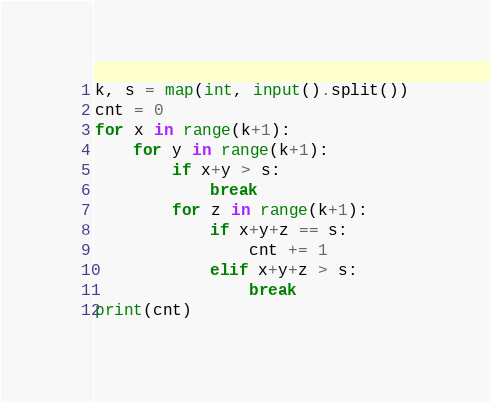Convert code to text. <code><loc_0><loc_0><loc_500><loc_500><_Python_>k, s = map(int, input().split())
cnt = 0
for x in range(k+1):
    for y in range(k+1):
        if x+y > s:
            break
        for z in range(k+1):
            if x+y+z == s:
                cnt += 1
            elif x+y+z > s:
                break
print(cnt)
</code> 